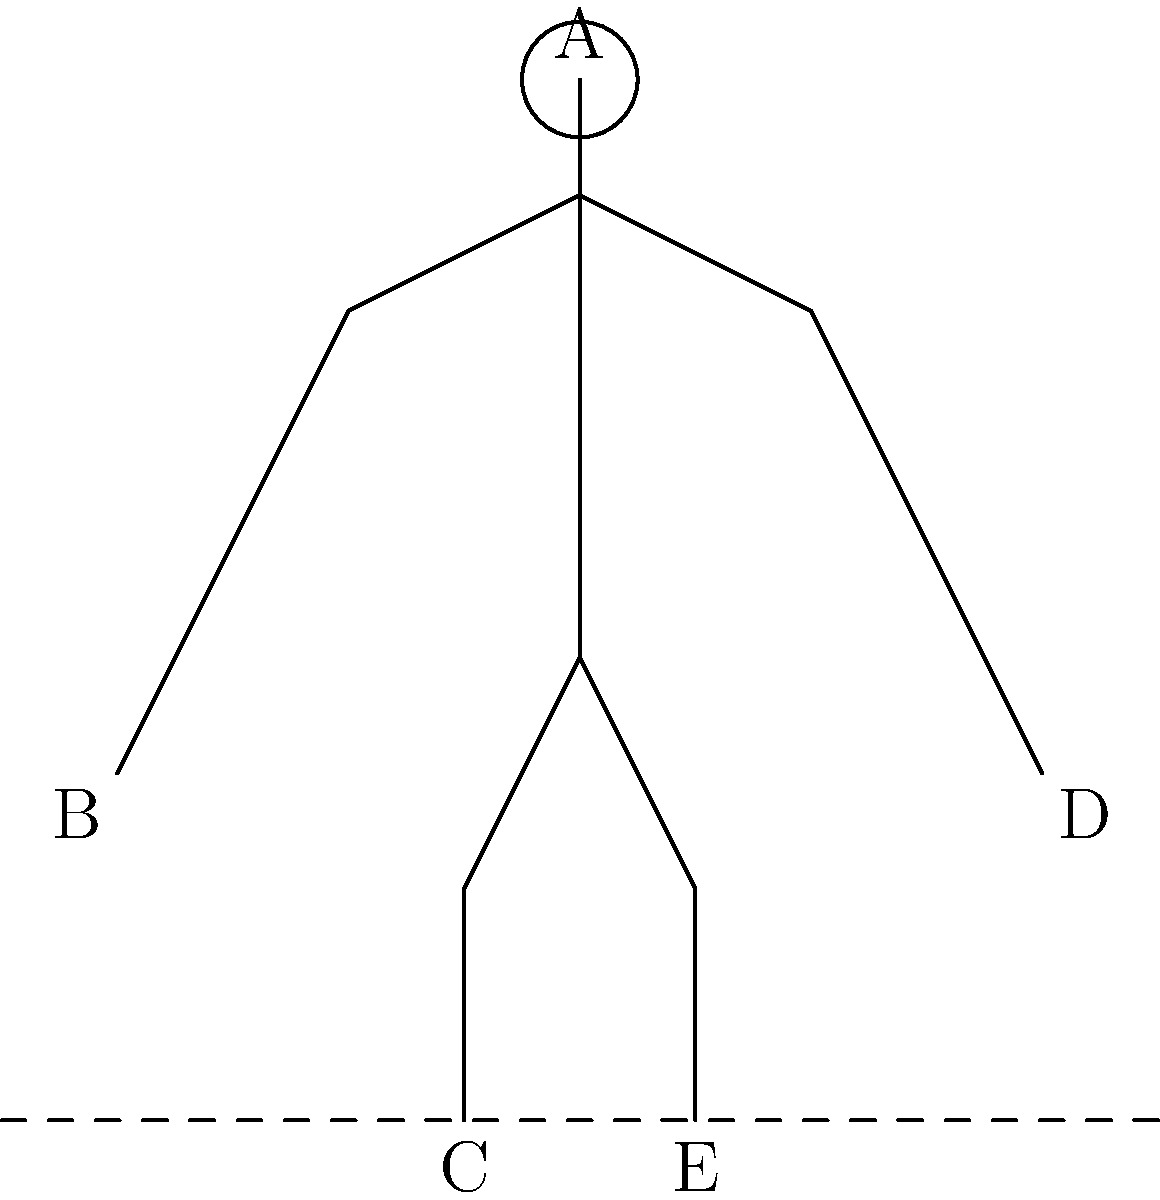In the given figure of a human form in a dynamic pose, what is the approximate ratio of the total height (from top of the head to the feet) to the length of the arm (from shoulder to hand)? How does this compare to the standard anatomical proportions, and what artistic considerations might influence deviations from these standards? To answer this question, let's break it down into steps:

1. Analyze the given figure:
   - Point A represents the top of the head
   - Points B and D represent the hands
   - Points C and E represent the feet
   - The shoulders are located slightly below the neck

2. Estimate the total height:
   - The distance from A to C (or E) represents the total height
   - This appears to be approximately 9 units

3. Estimate the arm length:
   - The distance from the shoulder to B (or D) represents the arm length
   - This appears to be approximately 4 units

4. Calculate the ratio:
   - Ratio = Total height : Arm length
   - Ratio ≈ 9 : 4 ≈ 2.25 : 1

5. Compare to standard anatomical proportions:
   - In classical figure drawing, the total height is often divided into 7.5 or 8 "head lengths"
   - The arm length (including the hand) is typically about 3 to 3.5 head lengths
   - This gives a standard ratio of about 2.3 : 1 to 2.67 : 1

6. Artistic considerations for deviations:
   a) Style: Exaggerated proportions can create a specific aesthetic or convey character traits
   b) Perspective: Foreshortening can alter perceived proportions
   c) Dynamic poses: Stretching or compressing forms can enhance the sense of movement
   d) Emotional expression: Altered proportions can emphasize gestures or feelings
   e) Character design: Unique proportions can define distinctive characters or species

The figure in the drawing shows slightly elongated arms compared to classical proportions, which could be an artistic choice to enhance the dynamic feel of the pose or to emphasize the reach of the figure.
Answer: Ratio ≈ 2.25:1; slightly longer arms than standard proportions (2.3:1 to 2.67:1); artistic deviations consider style, perspective, dynamism, expression, and character design. 